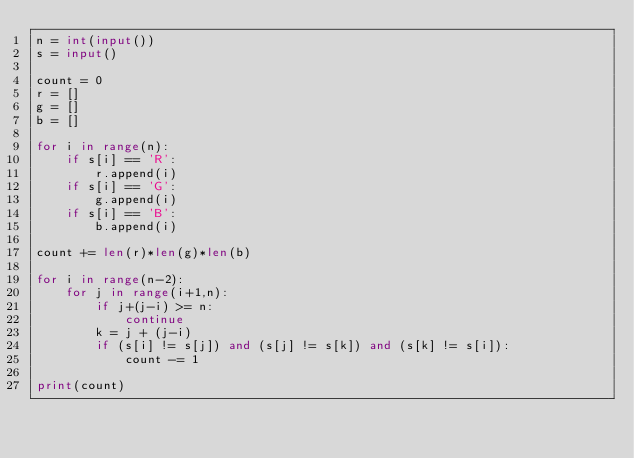<code> <loc_0><loc_0><loc_500><loc_500><_Python_>n = int(input())
s = input()

count = 0
r = []
g = []
b = []

for i in range(n):
    if s[i] == 'R':
        r.append(i)
    if s[i] == 'G':
        g.append(i)
    if s[i] == 'B':
        b.append(i)

count += len(r)*len(g)*len(b)

for i in range(n-2):
    for j in range(i+1,n):
        if j+(j-i) >= n:
            continue
        k = j + (j-i)
        if (s[i] != s[j]) and (s[j] != s[k]) and (s[k] != s[i]):
            count -= 1

print(count)
</code> 